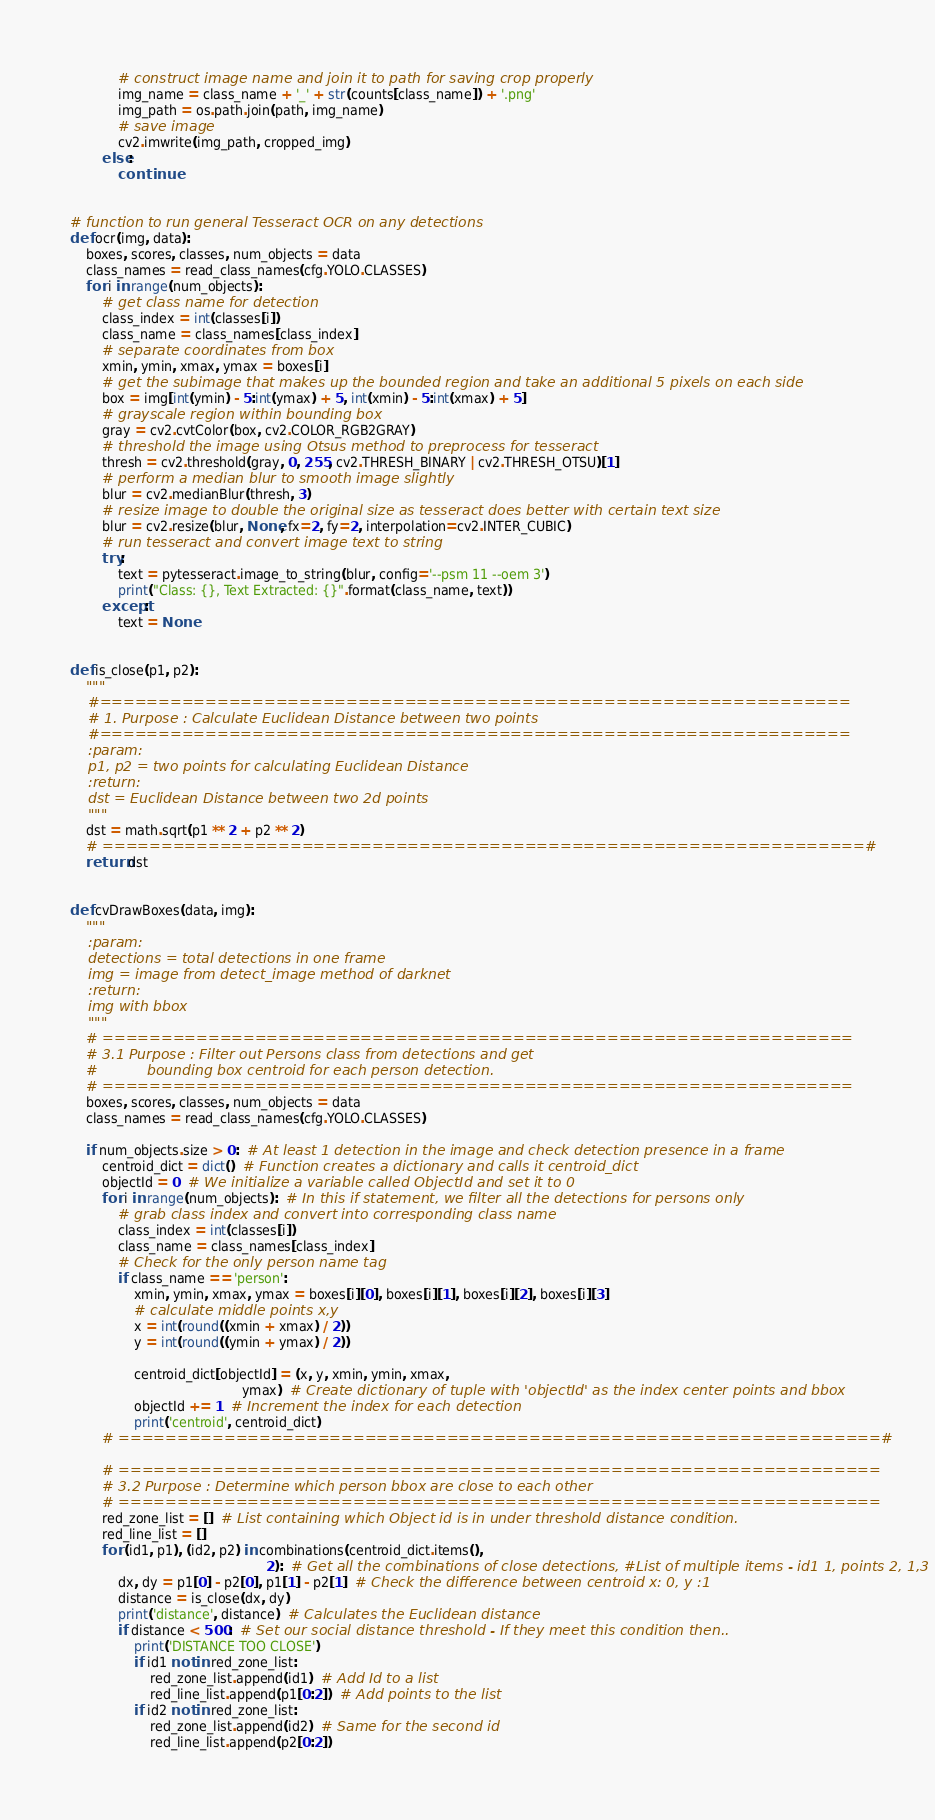Convert code to text. <code><loc_0><loc_0><loc_500><loc_500><_Python_>            # construct image name and join it to path for saving crop properly
            img_name = class_name + '_' + str(counts[class_name]) + '.png'
            img_path = os.path.join(path, img_name)
            # save image
            cv2.imwrite(img_path, cropped_img)
        else:
            continue


# function to run general Tesseract OCR on any detections
def ocr(img, data):
    boxes, scores, classes, num_objects = data
    class_names = read_class_names(cfg.YOLO.CLASSES)
    for i in range(num_objects):
        # get class name for detection
        class_index = int(classes[i])
        class_name = class_names[class_index]
        # separate coordinates from box
        xmin, ymin, xmax, ymax = boxes[i]
        # get the subimage that makes up the bounded region and take an additional 5 pixels on each side
        box = img[int(ymin) - 5:int(ymax) + 5, int(xmin) - 5:int(xmax) + 5]
        # grayscale region within bounding box
        gray = cv2.cvtColor(box, cv2.COLOR_RGB2GRAY)
        # threshold the image using Otsus method to preprocess for tesseract
        thresh = cv2.threshold(gray, 0, 255, cv2.THRESH_BINARY | cv2.THRESH_OTSU)[1]
        # perform a median blur to smooth image slightly
        blur = cv2.medianBlur(thresh, 3)
        # resize image to double the original size as tesseract does better with certain text size
        blur = cv2.resize(blur, None, fx=2, fy=2, interpolation=cv2.INTER_CUBIC)
        # run tesseract and convert image text to string
        try:
            text = pytesseract.image_to_string(blur, config='--psm 11 --oem 3')
            print("Class: {}, Text Extracted: {}".format(class_name, text))
        except:
            text = None


def is_close(p1, p2):
    """
    #================================================================
    # 1. Purpose : Calculate Euclidean Distance between two points
    #================================================================
    :param:
    p1, p2 = two points for calculating Euclidean Distance
    :return:
    dst = Euclidean Distance between two 2d points
    """
    dst = math.sqrt(p1 ** 2 + p2 ** 2)
    # =================================================================#
    return dst


def cvDrawBoxes(data, img):
    """
    :param:
    detections = total detections in one frame
    img = image from detect_image method of darknet
    :return:
    img with bbox
    """
    # ================================================================
    # 3.1 Purpose : Filter out Persons class from detections and get
    #           bounding box centroid for each person detection.
    # ================================================================
    boxes, scores, classes, num_objects = data
    class_names = read_class_names(cfg.YOLO.CLASSES)

    if num_objects.size > 0:  # At least 1 detection in the image and check detection presence in a frame
        centroid_dict = dict()  # Function creates a dictionary and calls it centroid_dict
        objectId = 0  # We initialize a variable called ObjectId and set it to 0
        for i in range(num_objects):  # In this if statement, we filter all the detections for persons only
            # grab class index and convert into corresponding class name
            class_index = int(classes[i])
            class_name = class_names[class_index]
            # Check for the only person name tag
            if class_name == 'person':
                xmin, ymin, xmax, ymax = boxes[i][0], boxes[i][1], boxes[i][2], boxes[i][3]
                # calculate middle points x,y
                x = int(round((xmin + xmax) / 2))
                y = int(round((ymin + ymax) / 2))

                centroid_dict[objectId] = (x, y, xmin, ymin, xmax,
                                           ymax)  # Create dictionary of tuple with 'objectId' as the index center points and bbox
                objectId += 1  # Increment the index for each detection
                print('centroid', centroid_dict)
        # =================================================================#

        # =================================================================
        # 3.2 Purpose : Determine which person bbox are close to each other
        # =================================================================
        red_zone_list = []  # List containing which Object id is in under threshold distance condition.
        red_line_list = []
        for (id1, p1), (id2, p2) in combinations(centroid_dict.items(),
                                                 2):  # Get all the combinations of close detections, #List of multiple items - id1 1, points 2, 1,3
            dx, dy = p1[0] - p2[0], p1[1] - p2[1]  # Check the difference between centroid x: 0, y :1
            distance = is_close(dx, dy)
            print('distance', distance)  # Calculates the Euclidean distance
            if distance < 500:  # Set our social distance threshold - If they meet this condition then..
                print('DISTANCE TOO CLOSE')
                if id1 not in red_zone_list:
                    red_zone_list.append(id1)  # Add Id to a list
                    red_line_list.append(p1[0:2])  # Add points to the list
                if id2 not in red_zone_list:
                    red_zone_list.append(id2)  # Same for the second id
                    red_line_list.append(p2[0:2])</code> 